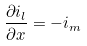Convert formula to latex. <formula><loc_0><loc_0><loc_500><loc_500>\frac { \partial i _ { l } } { \partial x } = - i _ { m }</formula> 